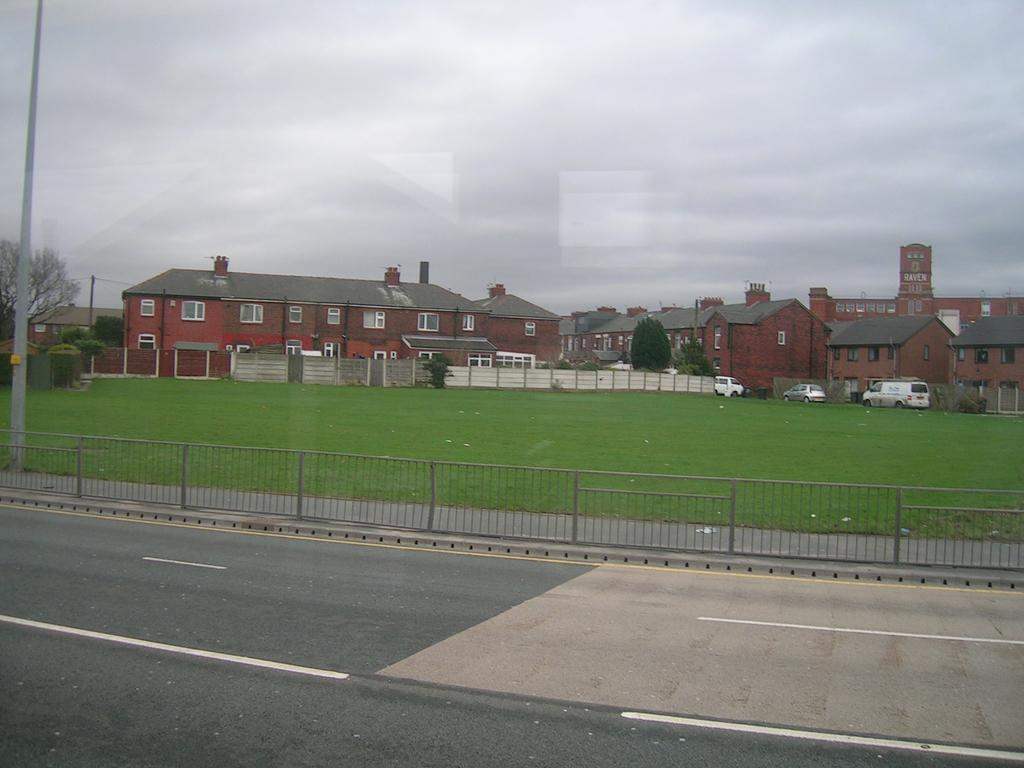What type of structures can be seen in the image? There are buildings in the image. What other natural elements are present in the image? There are trees in the image. What man-made objects can be seen in the image? There are vehicles, fences, and poles in the image. What part of the natural environment is visible in the image? The sky is visible at the top of the image, and the ground is visible at the bottom of the image. What type of pathway is present in the image? There is a road at the bottom of the image. How many bubbles can be seen floating in the sky in the image? There are no bubbles present in the image; the sky is visible but not filled with bubbles. What time is displayed on the clocks in the image? There are no clocks present in the image, so it is not possible to determine the time. 